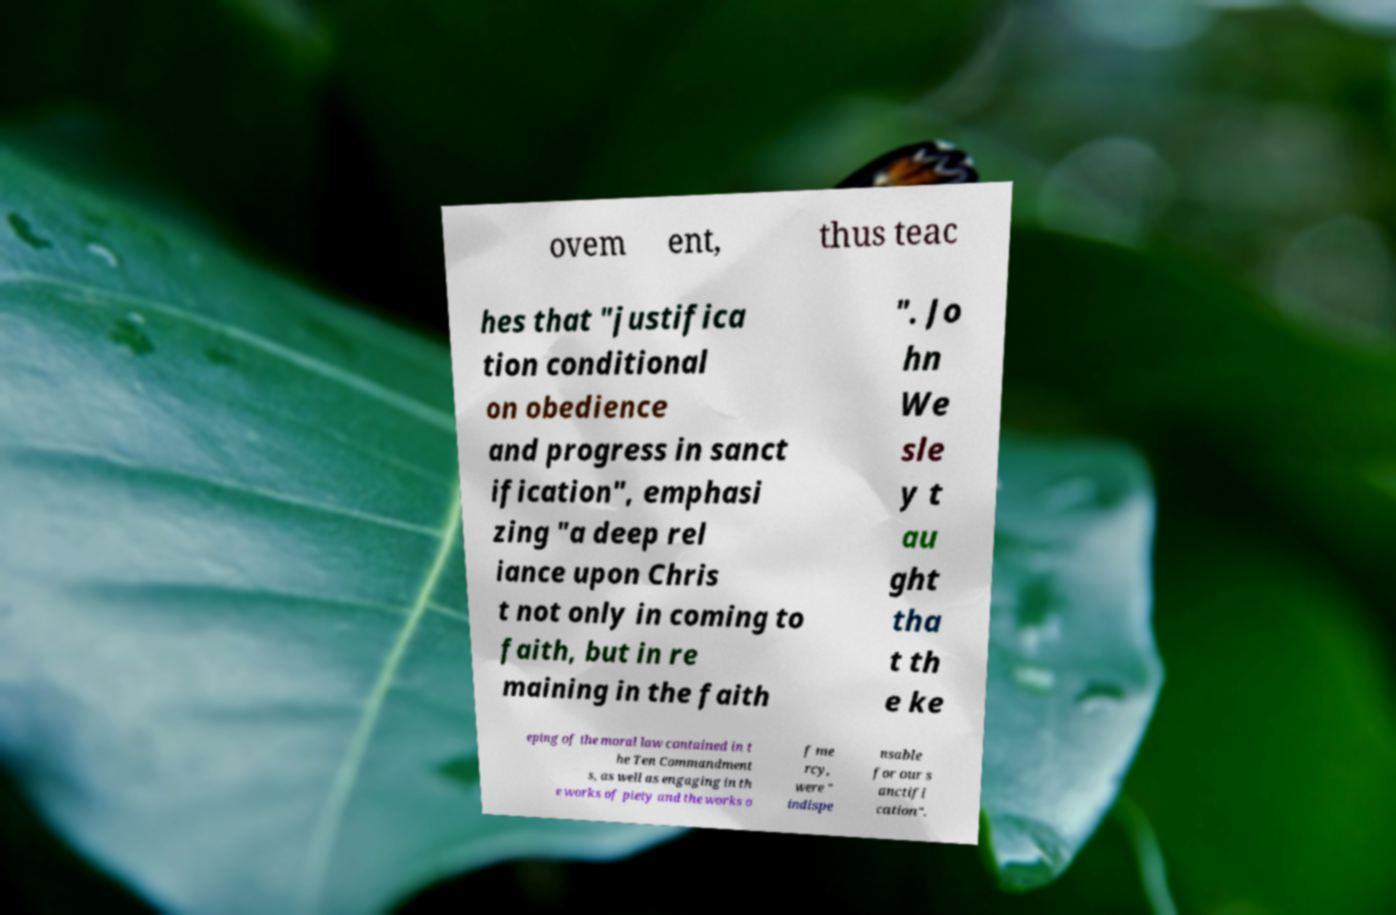I need the written content from this picture converted into text. Can you do that? ovem ent, thus teac hes that "justifica tion conditional on obedience and progress in sanct ification", emphasi zing "a deep rel iance upon Chris t not only in coming to faith, but in re maining in the faith ". Jo hn We sle y t au ght tha t th e ke eping of the moral law contained in t he Ten Commandment s, as well as engaging in th e works of piety and the works o f me rcy, were " indispe nsable for our s anctifi cation". 